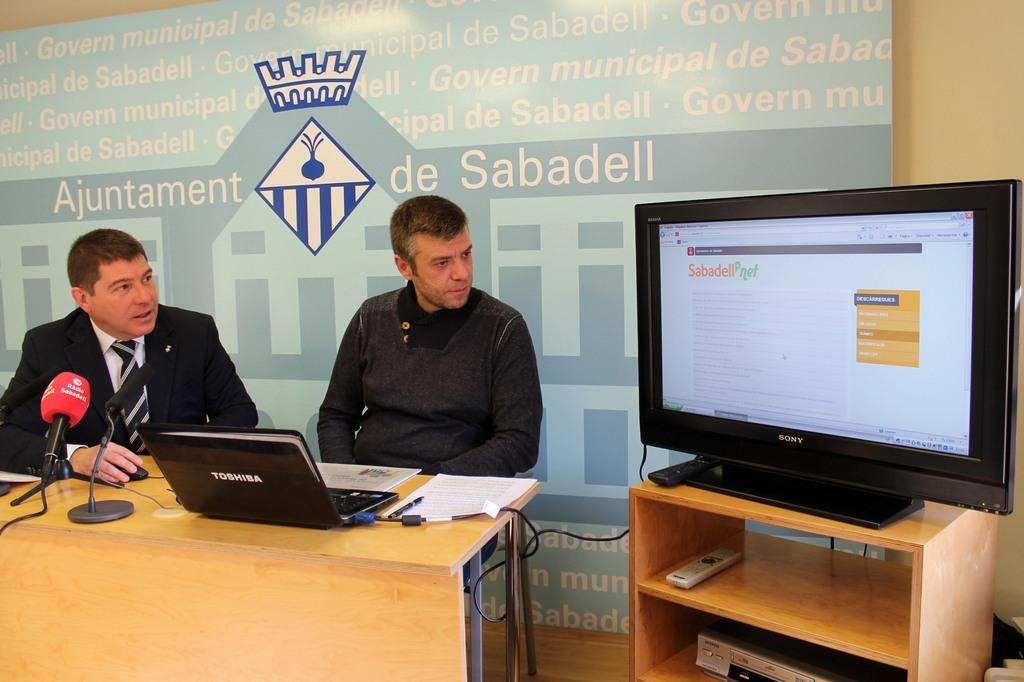How many people are in the image? There are two persons in the image. What are the two persons doing in the image? The two persons are sitting in front of a table. What objects can be seen on the table? There is a laptop and a mic on the table. What is located beside the two persons? There is a television beside the two persons. What type of dinosaurs can be seen in the image? There are no dinosaurs present in the image. What decision are the two persons making in the image? The image does not provide any information about a decision being made by the two persons. 